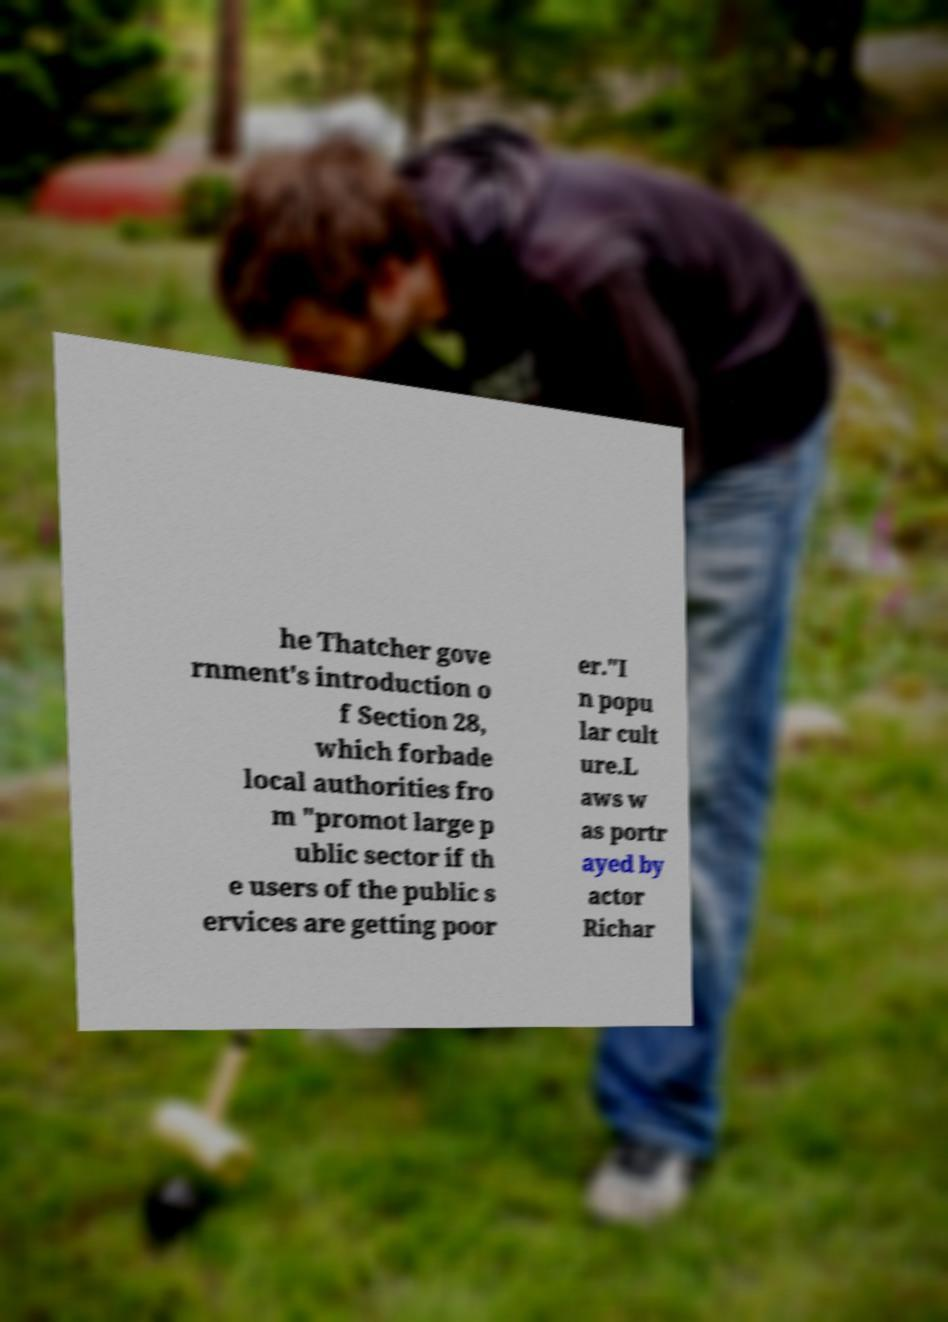There's text embedded in this image that I need extracted. Can you transcribe it verbatim? he Thatcher gove rnment's introduction o f Section 28, which forbade local authorities fro m "promot large p ublic sector if th e users of the public s ervices are getting poor er."I n popu lar cult ure.L aws w as portr ayed by actor Richar 